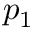Convert formula to latex. <formula><loc_0><loc_0><loc_500><loc_500>p _ { 1 }</formula> 